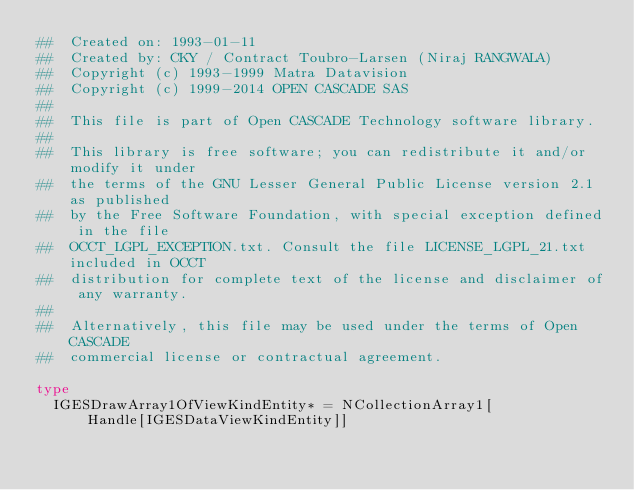<code> <loc_0><loc_0><loc_500><loc_500><_Nim_>##  Created on: 1993-01-11
##  Created by: CKY / Contract Toubro-Larsen (Niraj RANGWALA)
##  Copyright (c) 1993-1999 Matra Datavision
##  Copyright (c) 1999-2014 OPEN CASCADE SAS
##
##  This file is part of Open CASCADE Technology software library.
##
##  This library is free software; you can redistribute it and/or modify it under
##  the terms of the GNU Lesser General Public License version 2.1 as published
##  by the Free Software Foundation, with special exception defined in the file
##  OCCT_LGPL_EXCEPTION.txt. Consult the file LICENSE_LGPL_21.txt included in OCCT
##  distribution for complete text of the license and disclaimer of any warranty.
##
##  Alternatively, this file may be used under the terms of Open CASCADE
##  commercial license or contractual agreement.

type
  IGESDrawArray1OfViewKindEntity* = NCollectionArray1[
      Handle[IGESDataViewKindEntity]]


























</code> 